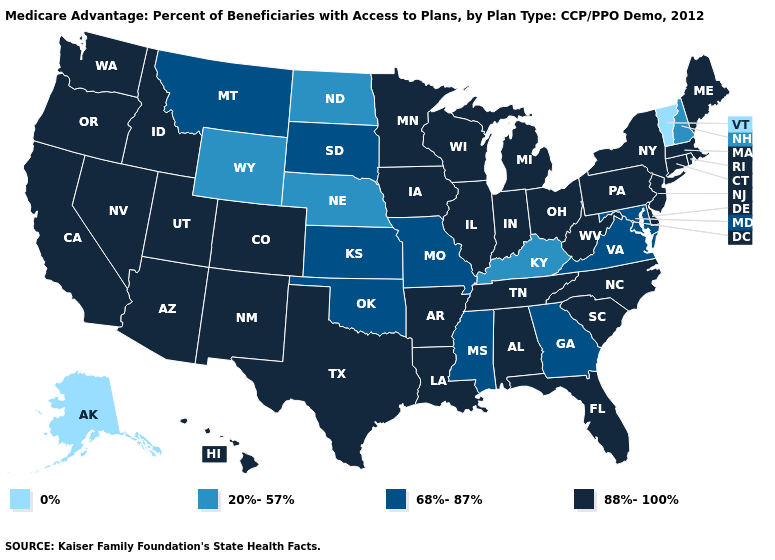Among the states that border Mississippi , which have the lowest value?
Quick response, please. Alabama, Arkansas, Louisiana, Tennessee. Among the states that border Delaware , does Maryland have the highest value?
Answer briefly. No. Name the states that have a value in the range 0%?
Quick response, please. Alaska, Vermont. Name the states that have a value in the range 68%-87%?
Keep it brief. Georgia, Kansas, Maryland, Missouri, Mississippi, Montana, Oklahoma, South Dakota, Virginia. What is the value of Oklahoma?
Keep it brief. 68%-87%. What is the value of Mississippi?
Quick response, please. 68%-87%. What is the value of Kansas?
Answer briefly. 68%-87%. Name the states that have a value in the range 0%?
Short answer required. Alaska, Vermont. Does Utah have the same value as Georgia?
Keep it brief. No. What is the highest value in the MidWest ?
Keep it brief. 88%-100%. Name the states that have a value in the range 68%-87%?
Give a very brief answer. Georgia, Kansas, Maryland, Missouri, Mississippi, Montana, Oklahoma, South Dakota, Virginia. What is the lowest value in the USA?
Be succinct. 0%. What is the value of Washington?
Answer briefly. 88%-100%. Which states have the lowest value in the USA?
Short answer required. Alaska, Vermont. What is the value of Georgia?
Concise answer only. 68%-87%. 